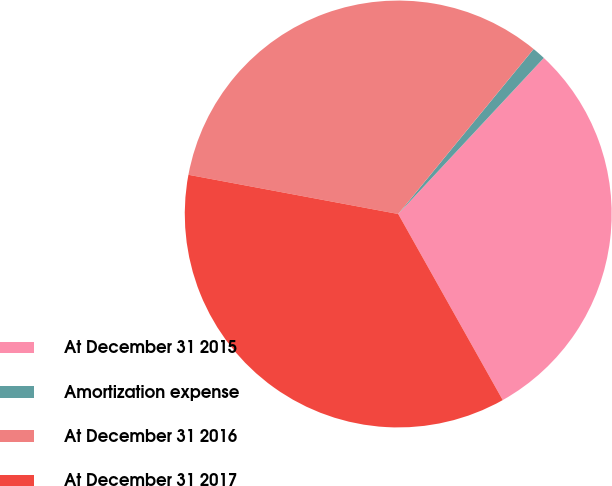Convert chart to OTSL. <chart><loc_0><loc_0><loc_500><loc_500><pie_chart><fcel>At December 31 2015<fcel>Amortization expense<fcel>At December 31 2016<fcel>At December 31 2017<nl><fcel>29.91%<fcel>1.01%<fcel>33.0%<fcel>36.09%<nl></chart> 